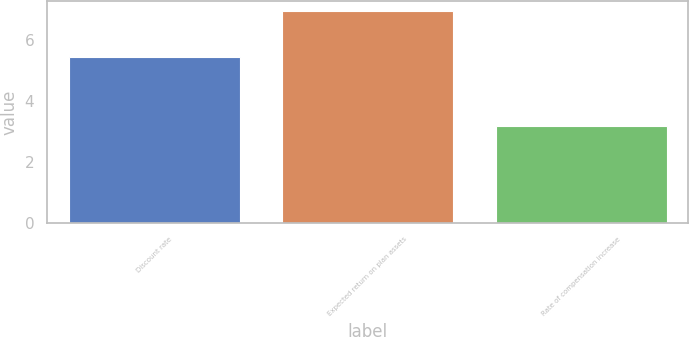<chart> <loc_0><loc_0><loc_500><loc_500><bar_chart><fcel>Discount rate<fcel>Expected return on plan assets<fcel>Rate of compensation increase<nl><fcel>5.43<fcel>6.94<fcel>3.17<nl></chart> 